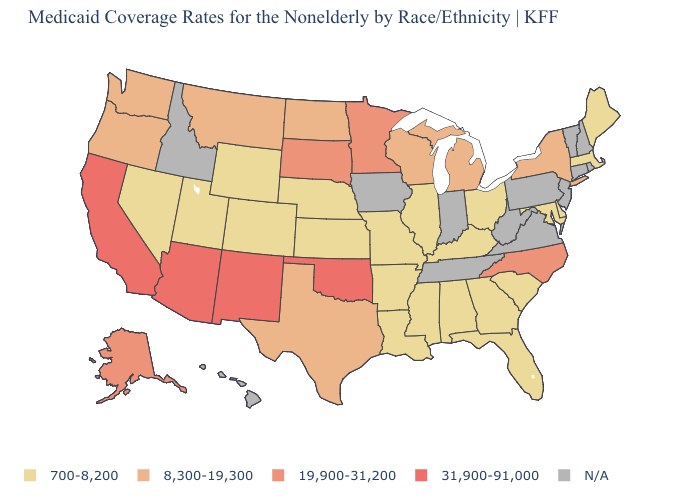Among the states that border Illinois , which have the highest value?
Quick response, please. Wisconsin. What is the value of Alabama?
Answer briefly. 700-8,200. What is the value of Massachusetts?
Be succinct. 700-8,200. What is the value of New York?
Concise answer only. 8,300-19,300. What is the value of South Carolina?
Concise answer only. 700-8,200. What is the highest value in states that border Kentucky?
Be succinct. 700-8,200. Name the states that have a value in the range 700-8,200?
Quick response, please. Alabama, Arkansas, Colorado, Delaware, Florida, Georgia, Illinois, Kansas, Kentucky, Louisiana, Maine, Maryland, Massachusetts, Mississippi, Missouri, Nebraska, Nevada, Ohio, South Carolina, Utah, Wyoming. Name the states that have a value in the range N/A?
Quick response, please. Connecticut, Hawaii, Idaho, Indiana, Iowa, New Hampshire, New Jersey, Pennsylvania, Rhode Island, Tennessee, Vermont, Virginia, West Virginia. Name the states that have a value in the range N/A?
Short answer required. Connecticut, Hawaii, Idaho, Indiana, Iowa, New Hampshire, New Jersey, Pennsylvania, Rhode Island, Tennessee, Vermont, Virginia, West Virginia. Among the states that border Iowa , does Minnesota have the highest value?
Short answer required. Yes. Name the states that have a value in the range 19,900-31,200?
Answer briefly. Alaska, Minnesota, North Carolina, South Dakota. What is the highest value in the Northeast ?
Keep it brief. 8,300-19,300. 